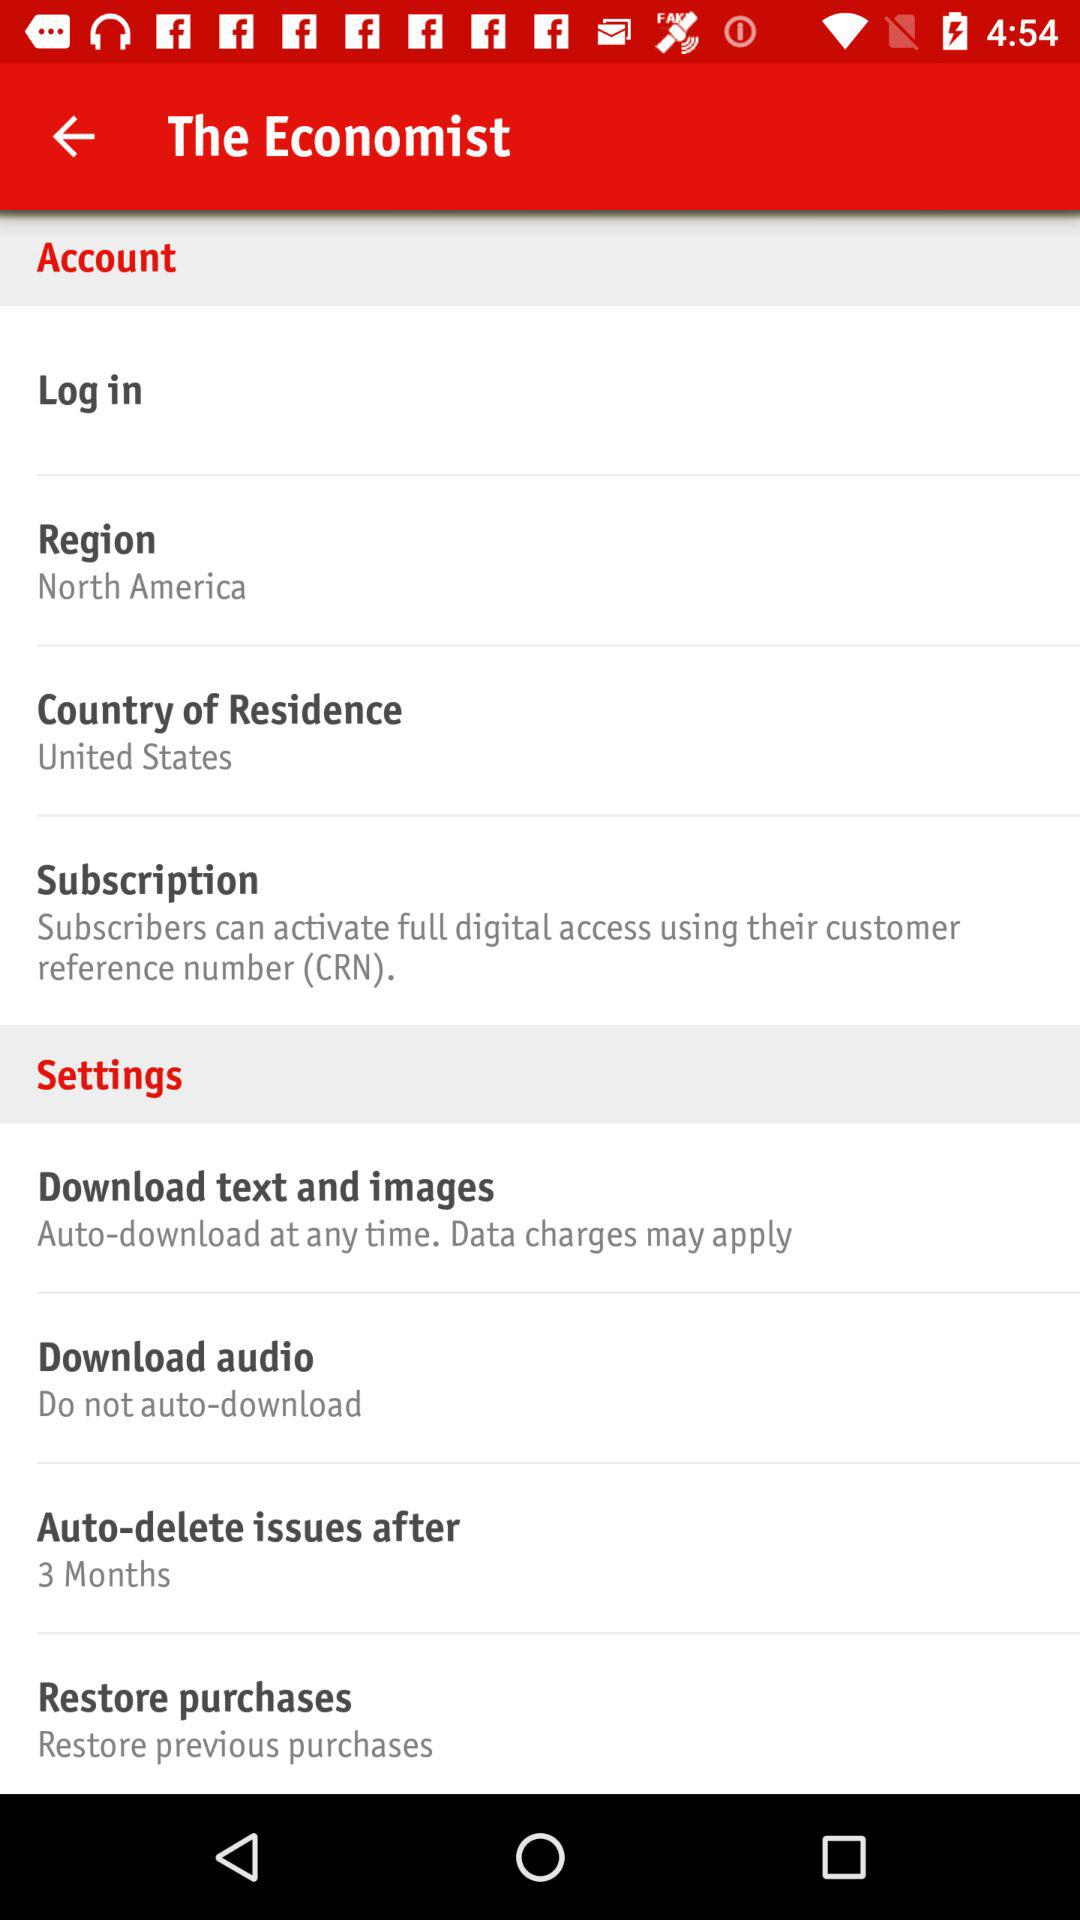Is "Account" checked or unchecked?
When the provided information is insufficient, respond with <no answer>. <no answer> 